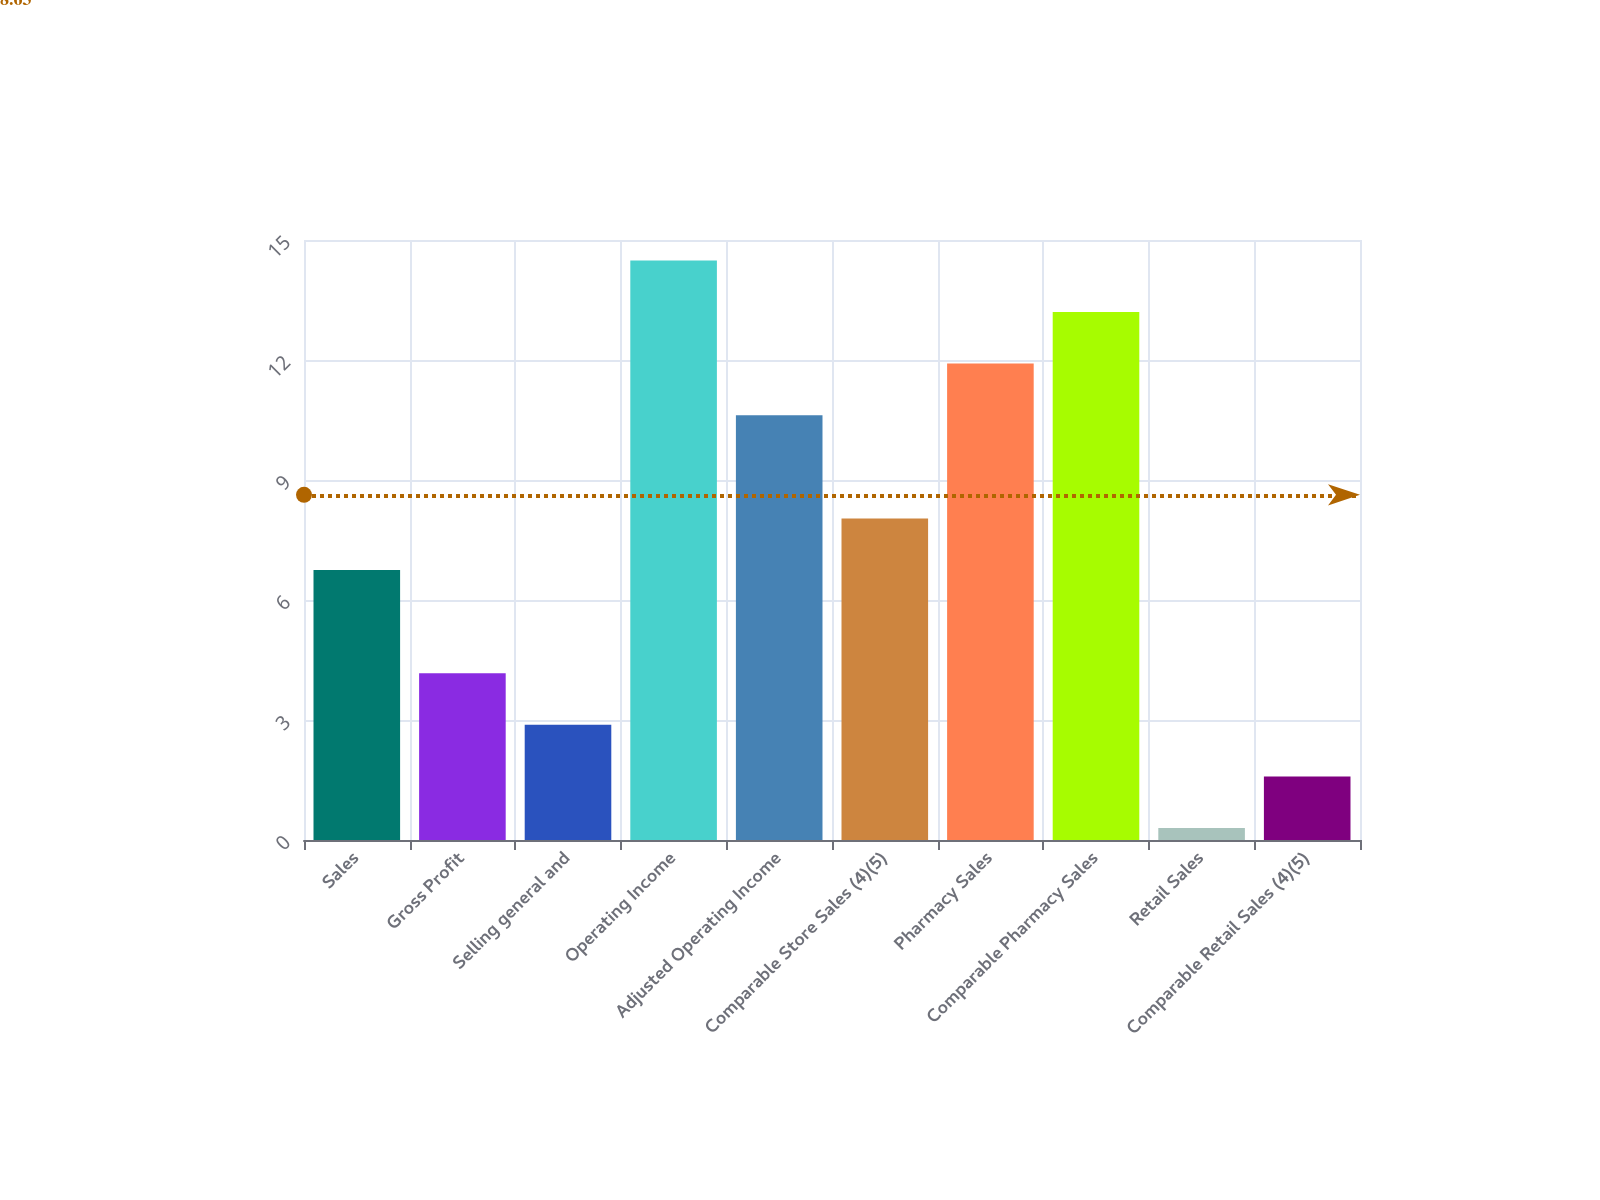Convert chart to OTSL. <chart><loc_0><loc_0><loc_500><loc_500><bar_chart><fcel>Sales<fcel>Gross Profit<fcel>Selling general and<fcel>Operating Income<fcel>Adjusted Operating Income<fcel>Comparable Store Sales (4)(5)<fcel>Pharmacy Sales<fcel>Comparable Pharmacy Sales<fcel>Retail Sales<fcel>Comparable Retail Sales (4)(5)<nl><fcel>6.75<fcel>4.17<fcel>2.88<fcel>14.49<fcel>10.62<fcel>8.04<fcel>11.91<fcel>13.2<fcel>0.3<fcel>1.59<nl></chart> 